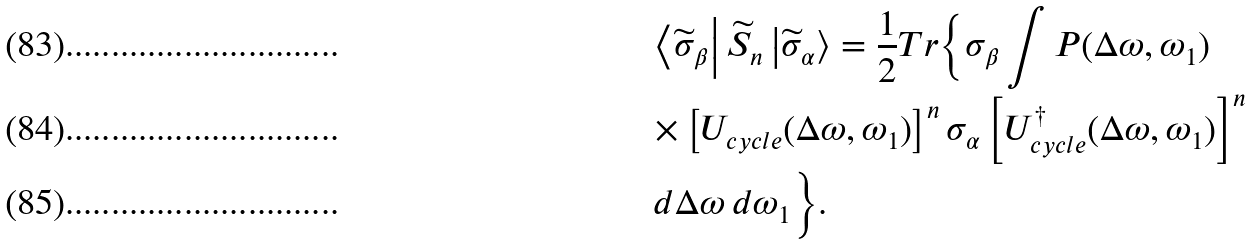Convert formula to latex. <formula><loc_0><loc_0><loc_500><loc_500>& \left \langle \widetilde { \sigma } _ { \beta } \right | \widetilde { S } _ { n } \left | \widetilde { \sigma } _ { \alpha } \right \rangle = \frac { 1 } { 2 } T r \Big { \{ } \sigma _ { \beta } \int P ( \Delta \omega , \omega _ { 1 } ) \\ & \times \left [ U _ { c y c l e } ( \Delta \omega , \omega _ { 1 } ) \right ] ^ { n } \sigma _ { \alpha } \left [ U _ { c y c l e } ^ { \dag } ( \Delta \omega , \omega _ { 1 } ) \right ] ^ { n } \\ & \, d \Delta \omega \, d \omega _ { 1 } \Big \} .</formula> 